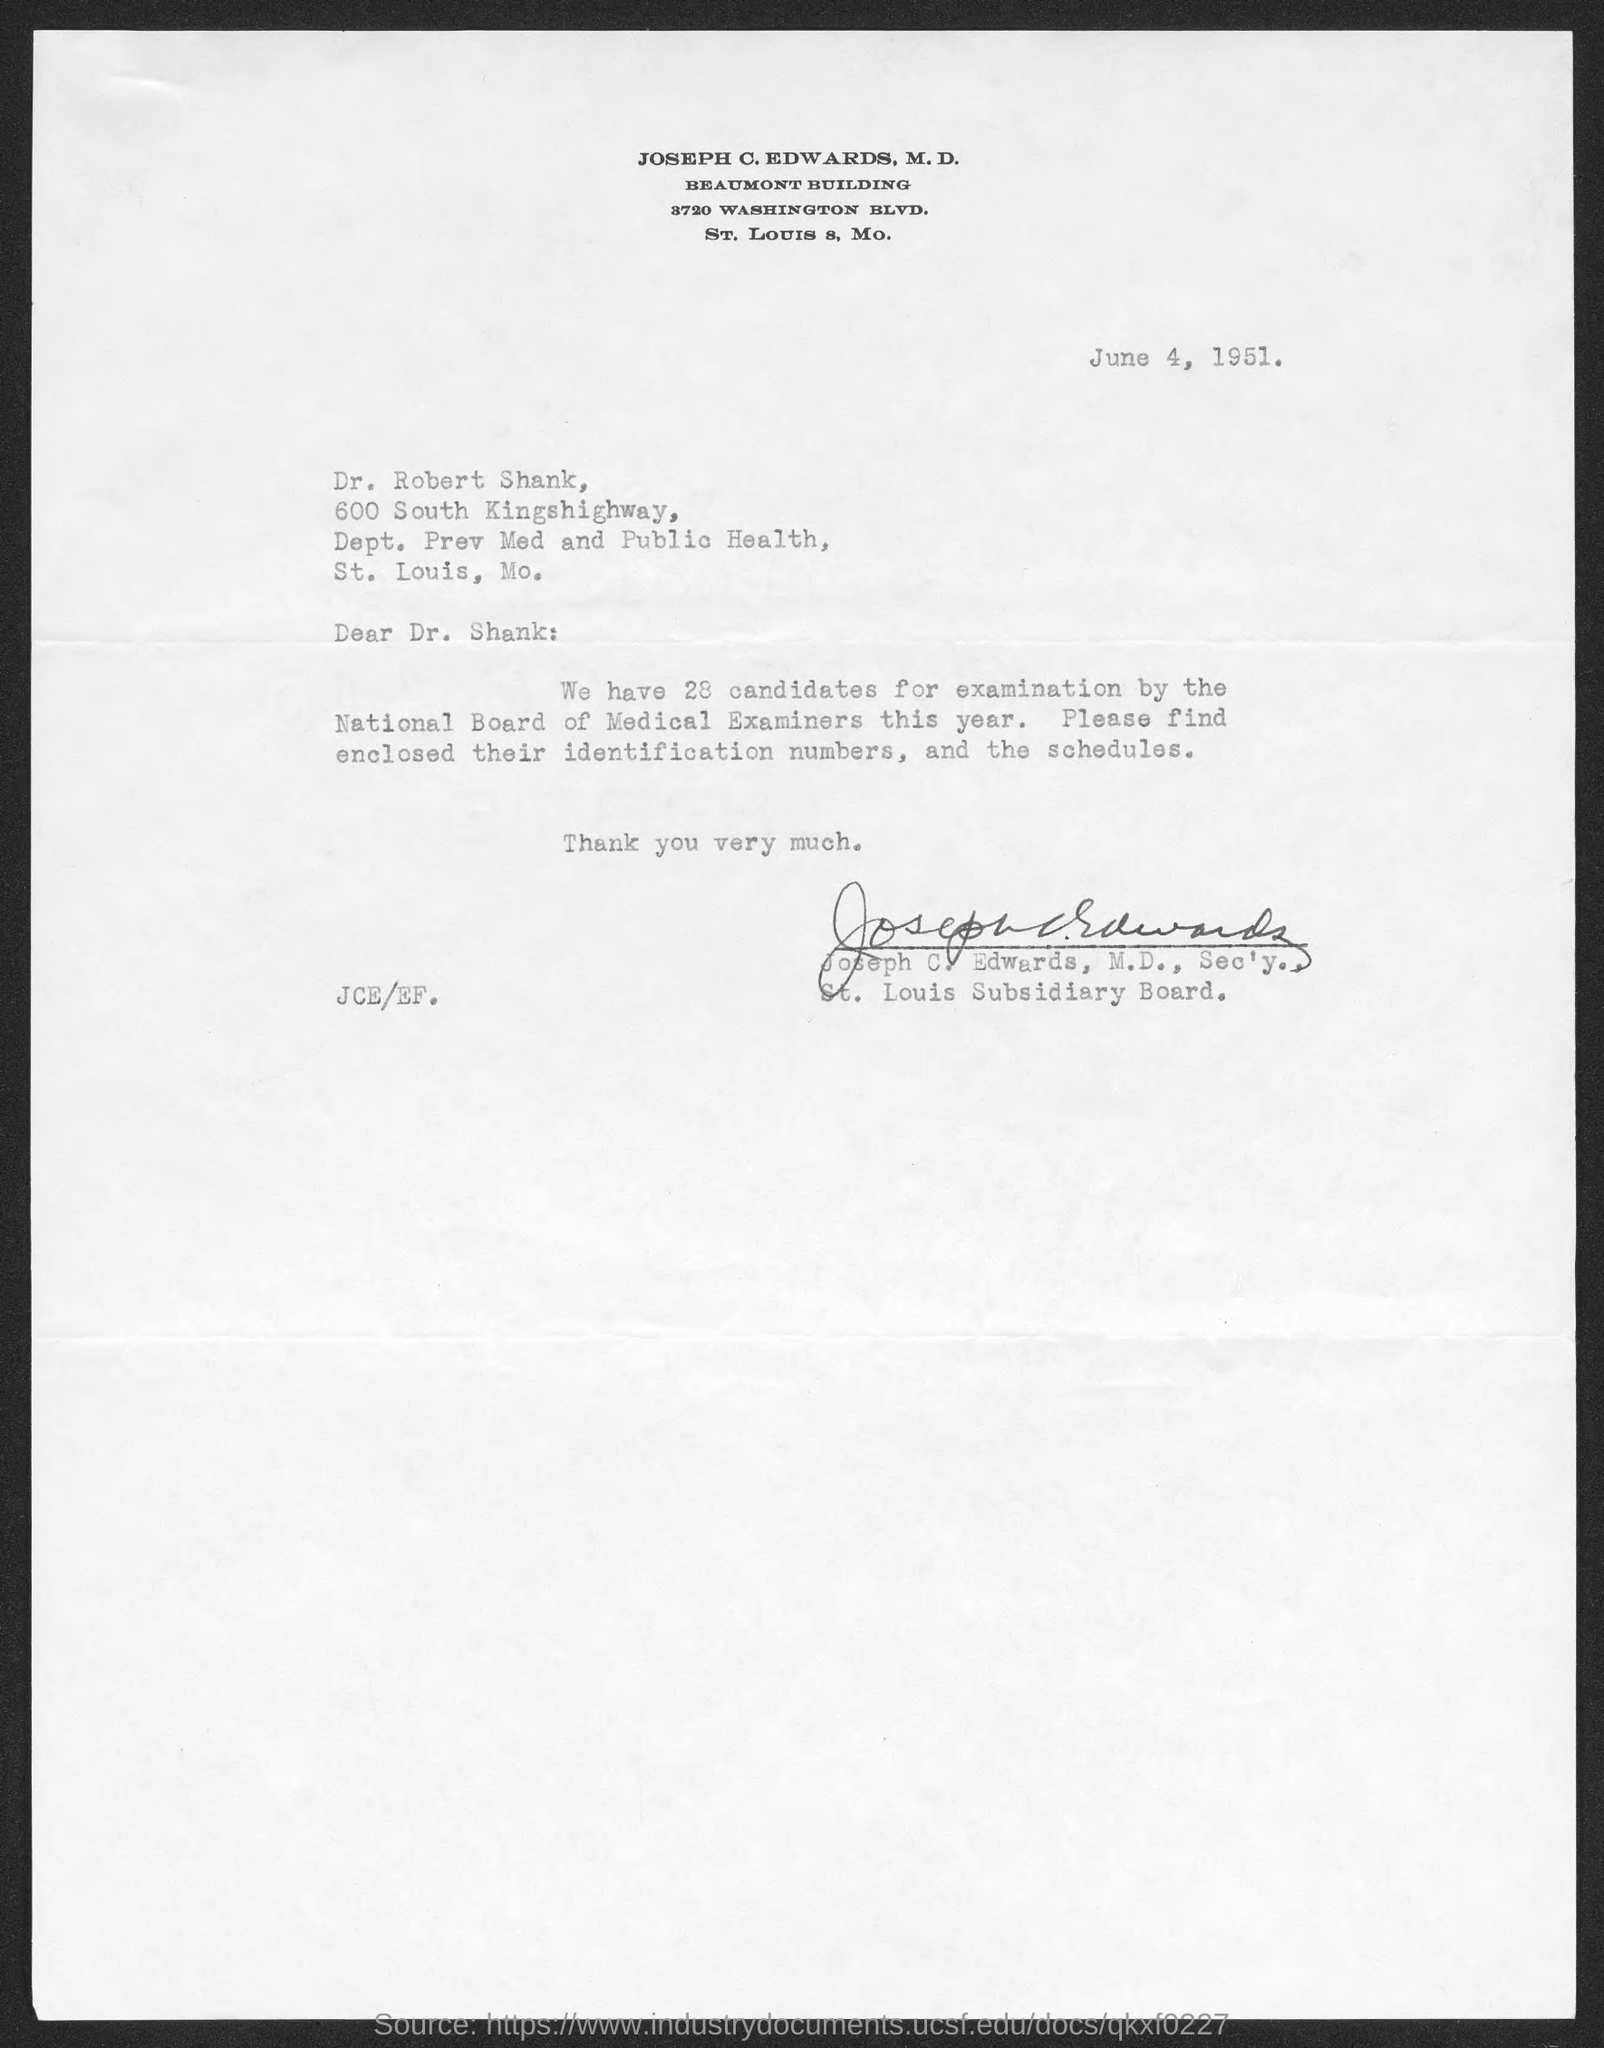Highlight a few significant elements in this photo. The memorandum is dated on June 4, 1951. 